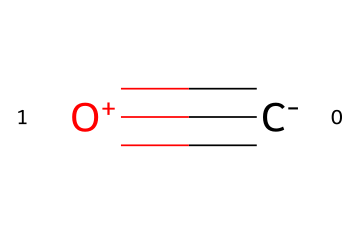What is the total number of atoms in this chemical? This chemical has one carbon atom (C) and one oxygen atom (O), so you sum these to find the total number of atoms.
Answer: two How many bonds are present in this chemical structure? The chemical structure has a triple bond between the carbon and the oxygen, which counts as one bond in total.
Answer: one What is the oxidation state of carbon in this molecule? In carbon monoxide, carbon is connected to oxygen with a triple bond, and its oxidation state is determined as +2 since it is bonded to a more electronegative atom (oxygen).
Answer: +2 What type of bond is present between the carbon and oxygen? The bond described in the SMILES is a triple bond, which indicates that there are three shared electron pairs between carbon and oxygen.
Answer: triple bond Which type of chemical is carbon monoxide classified as? Carbon monoxide is specifically classified as a toxic gas, which is significant due to its harmful effects on human health when inhaled.
Answer: toxic gas What is one major source of carbon monoxide in urban areas? The primary source of carbon monoxide in busy tourist areas, where vehicle emissions are common, is from vehicle exhaust.
Answer: vehicle exhaust 